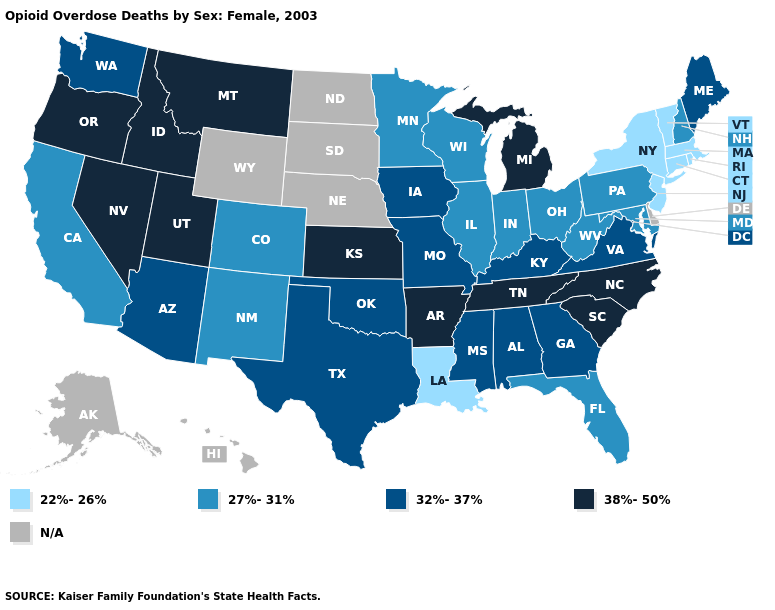What is the value of Arizona?
Give a very brief answer. 32%-37%. Is the legend a continuous bar?
Write a very short answer. No. What is the value of Maryland?
Keep it brief. 27%-31%. What is the value of Nebraska?
Concise answer only. N/A. What is the value of North Carolina?
Answer briefly. 38%-50%. Does the first symbol in the legend represent the smallest category?
Be succinct. Yes. What is the lowest value in states that border Pennsylvania?
Keep it brief. 22%-26%. What is the value of Kansas?
Quick response, please. 38%-50%. What is the lowest value in the MidWest?
Quick response, please. 27%-31%. Does the first symbol in the legend represent the smallest category?
Quick response, please. Yes. What is the value of Connecticut?
Short answer required. 22%-26%. Which states have the lowest value in the USA?
Be succinct. Connecticut, Louisiana, Massachusetts, New Jersey, New York, Rhode Island, Vermont. What is the lowest value in states that border Utah?
Short answer required. 27%-31%. 